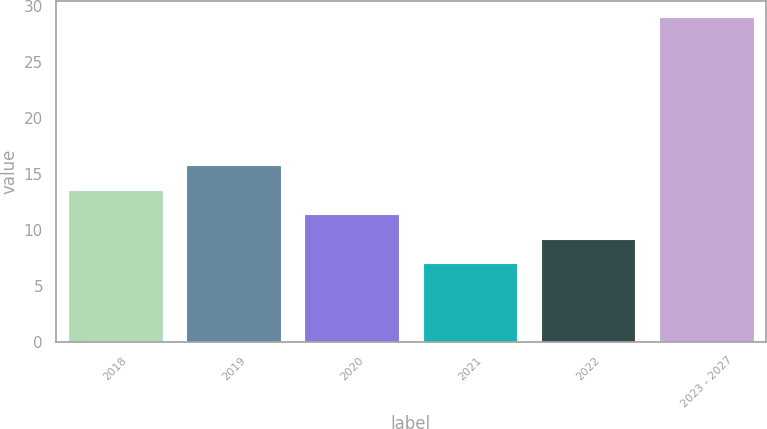<chart> <loc_0><loc_0><loc_500><loc_500><bar_chart><fcel>2018<fcel>2019<fcel>2020<fcel>2021<fcel>2022<fcel>2023 - 2027<nl><fcel>13.6<fcel>15.8<fcel>11.4<fcel>7<fcel>9.2<fcel>29<nl></chart> 